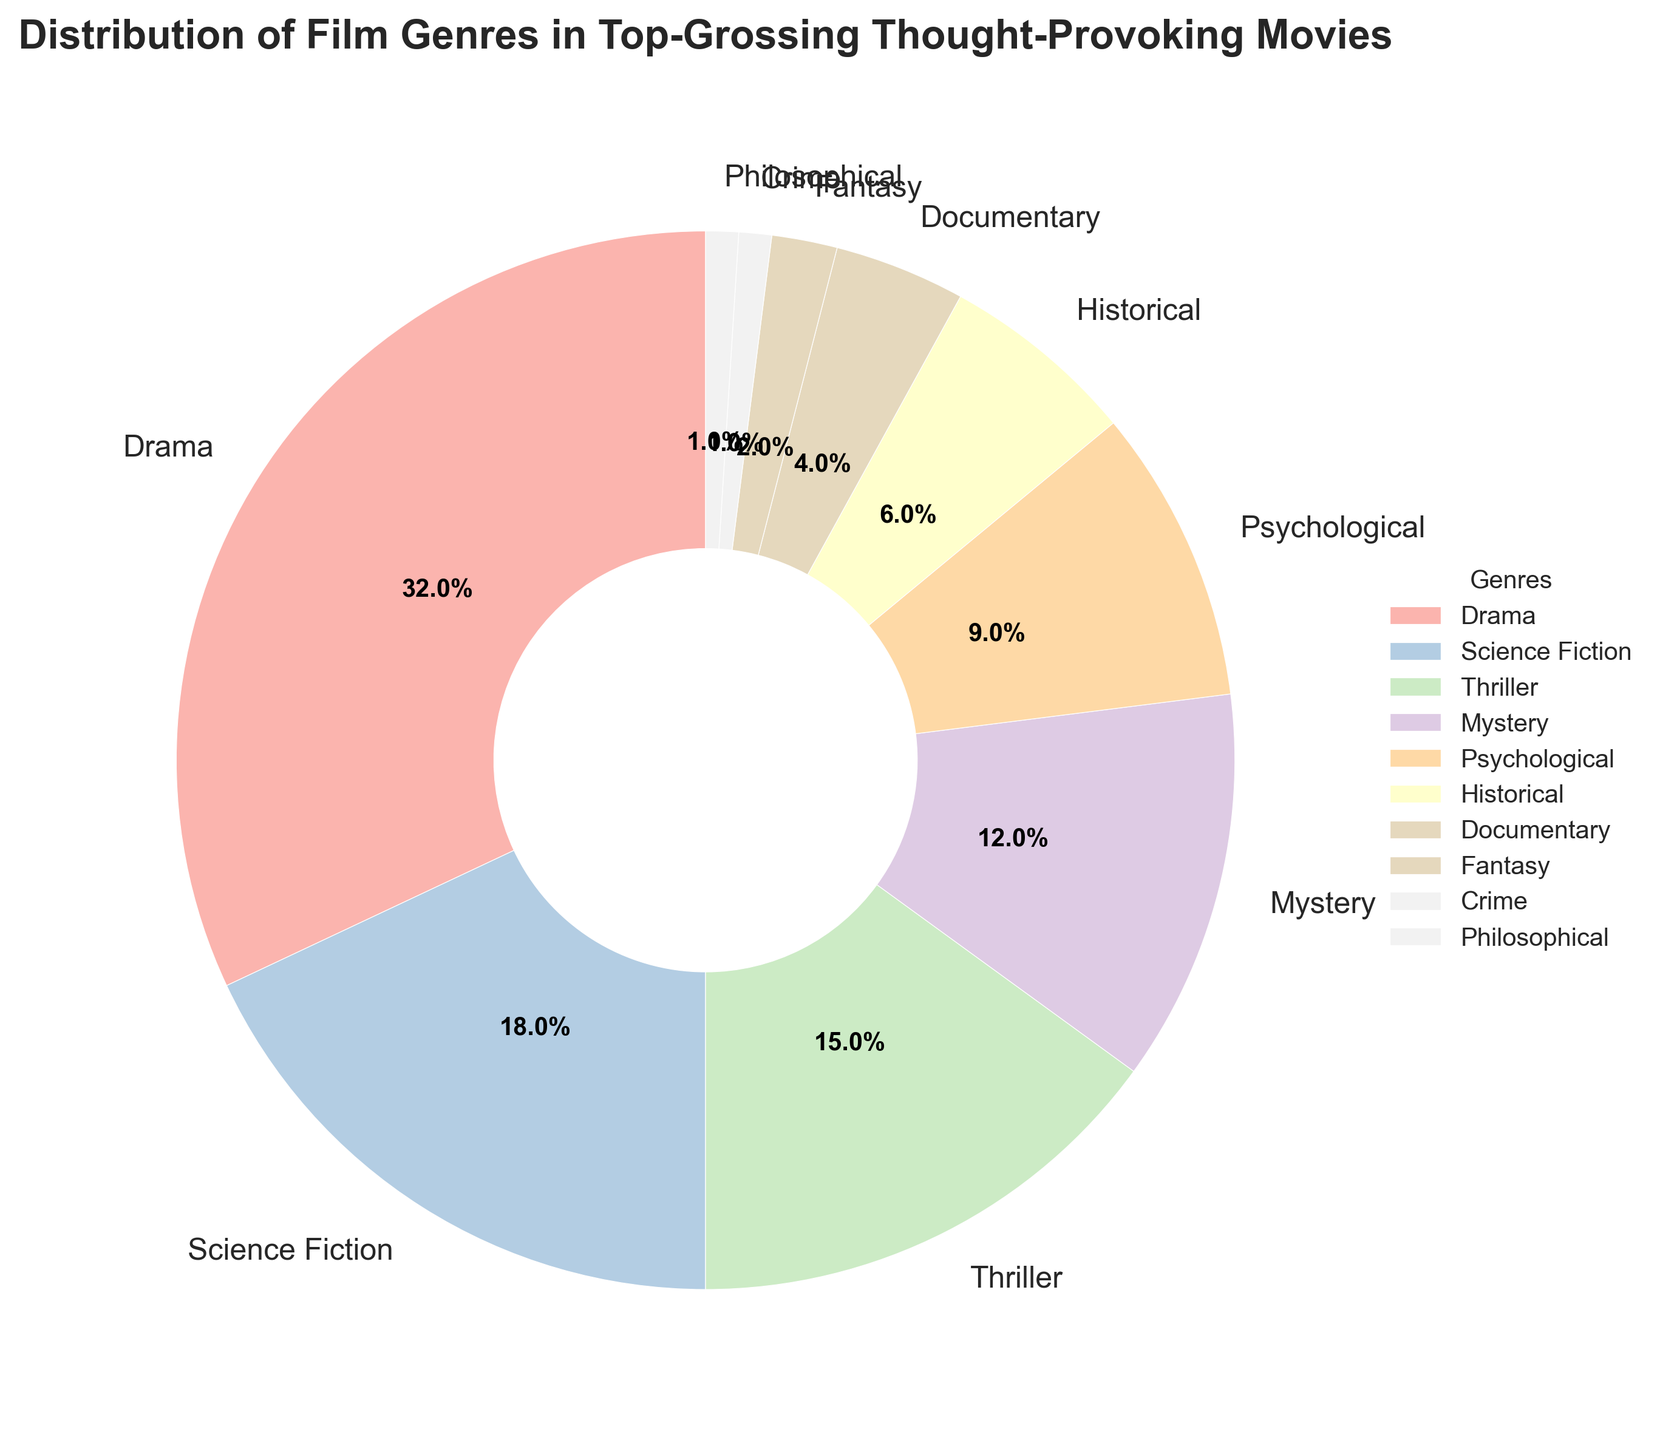What genre holds the largest slice of the pie chart? The largest slice of the pie chart represents the genre with the highest percentage. The chart shows that "Drama" occupies the largest section.
Answer: Drama What percentage of the top-grossing thought-provoking movies is composed of Science Fiction and Thriller genres combined? To find the combined percentage of Science Fiction and Thriller genres, sum their individual percentages: 18% + 15% = 33%.
Answer: 33% Which genres have a percentage less than or equal to 5%? By looking at the percentages of each genre on the pie chart, we can identify the genres with 5% or less. These genres are Documentary (4%), Fantasy (2%), Crime (1%), and Philosophical (1%).
Answer: Documentary, Fantasy, Crime, Philosophical How much more popular is Drama compared to Mystery in top-grossing thought-provoking movies? To find how much more popular Drama is compared to Mystery, subtract the percentage of Mystery from Drama: 32% - 12% = 20%.
Answer: 20% Which genre is represented by the smallest slice of the pie chart? The smallest slice of the pie chart represents the genre with the lowest percentage. The chart shows that Crime and Philosophical both occupy the smallest sections equally.
Answer: Crime, Philosophical What is the percentage difference between Psychological and Historical genres? Subtract the percentage of Historical from Psychological to find the difference: 9% - 6% = 3%.
Answer: 3% If all the genres with more than 10% are combined, what is their total percentage? Sum the percentages of all genres that have more than 10%, which are Drama (32%), Science Fiction (18%), and Thriller (15%): 32% + 18% + 15% = 65%.
Answer: 65% How does the size of the Fantasy genre slice compare visually to the Documentary genre slice? The Fantasy genre slice (2%) is visibly smaller than the Documentary genre slice (4%) by observing their respective sizes on the pie chart.
Answer: Smaller Is the sum of the percentages for Documentary, Fantasy, Crime, and Philosophical greater than 10%? Sum the percentages of Documentary (4%), Fantasy (2%), Crime (1%), and Philosophical (1%): 4% + 2% + 1% + 1% = 8%. This is less than 10%.
Answer: No 